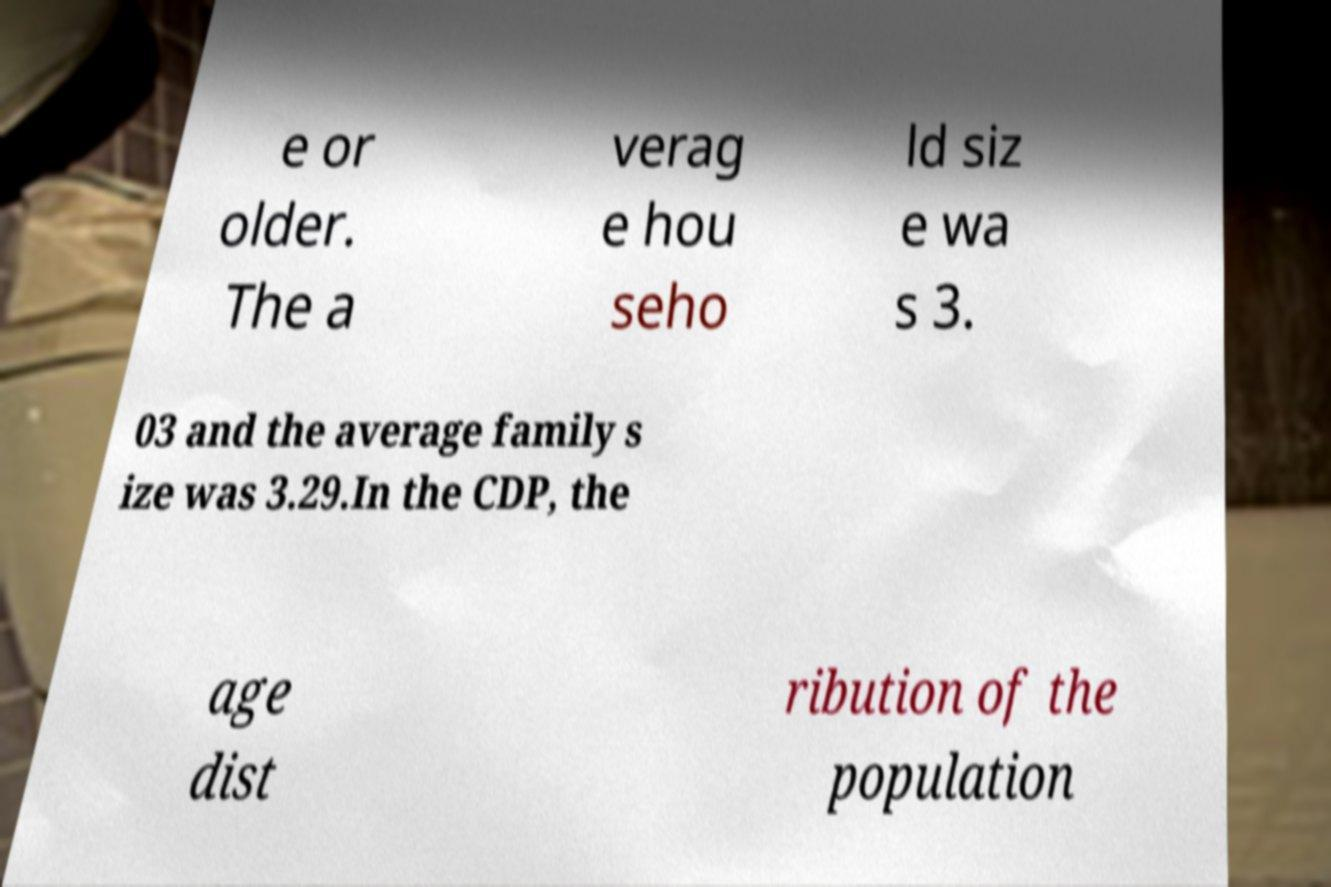What messages or text are displayed in this image? I need them in a readable, typed format. e or older. The a verag e hou seho ld siz e wa s 3. 03 and the average family s ize was 3.29.In the CDP, the age dist ribution of the population 